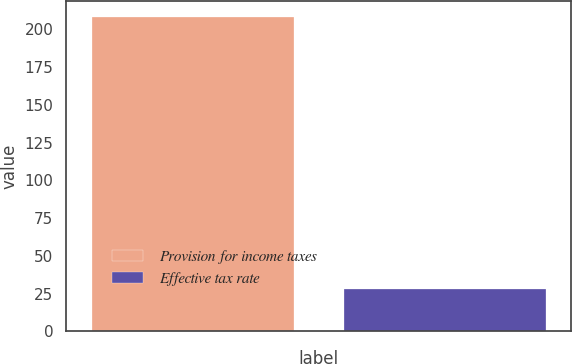<chart> <loc_0><loc_0><loc_500><loc_500><bar_chart><fcel>Provision for income taxes<fcel>Effective tax rate<nl><fcel>208.3<fcel>28.4<nl></chart> 